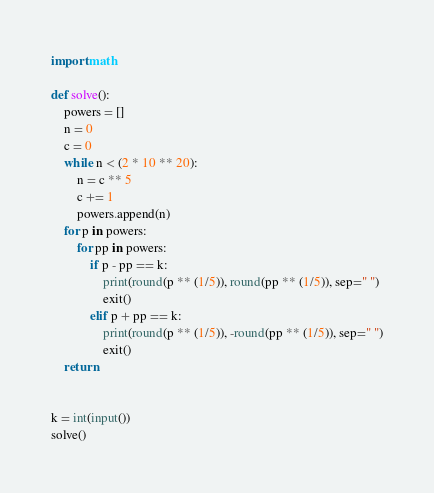Convert code to text. <code><loc_0><loc_0><loc_500><loc_500><_Python_>import math

def solve():
    powers = []
    n = 0
    c = 0
    while n < (2 * 10 ** 20):
        n = c ** 5
        c += 1
        powers.append(n)
    for p in powers:
        for pp in powers:
            if p - pp == k:
                print(round(p ** (1/5)), round(pp ** (1/5)), sep=" ")
                exit()
            elif p + pp == k:
                print(round(p ** (1/5)), -round(pp ** (1/5)), sep=" ")
                exit()
    return


k = int(input())
solve()
</code> 